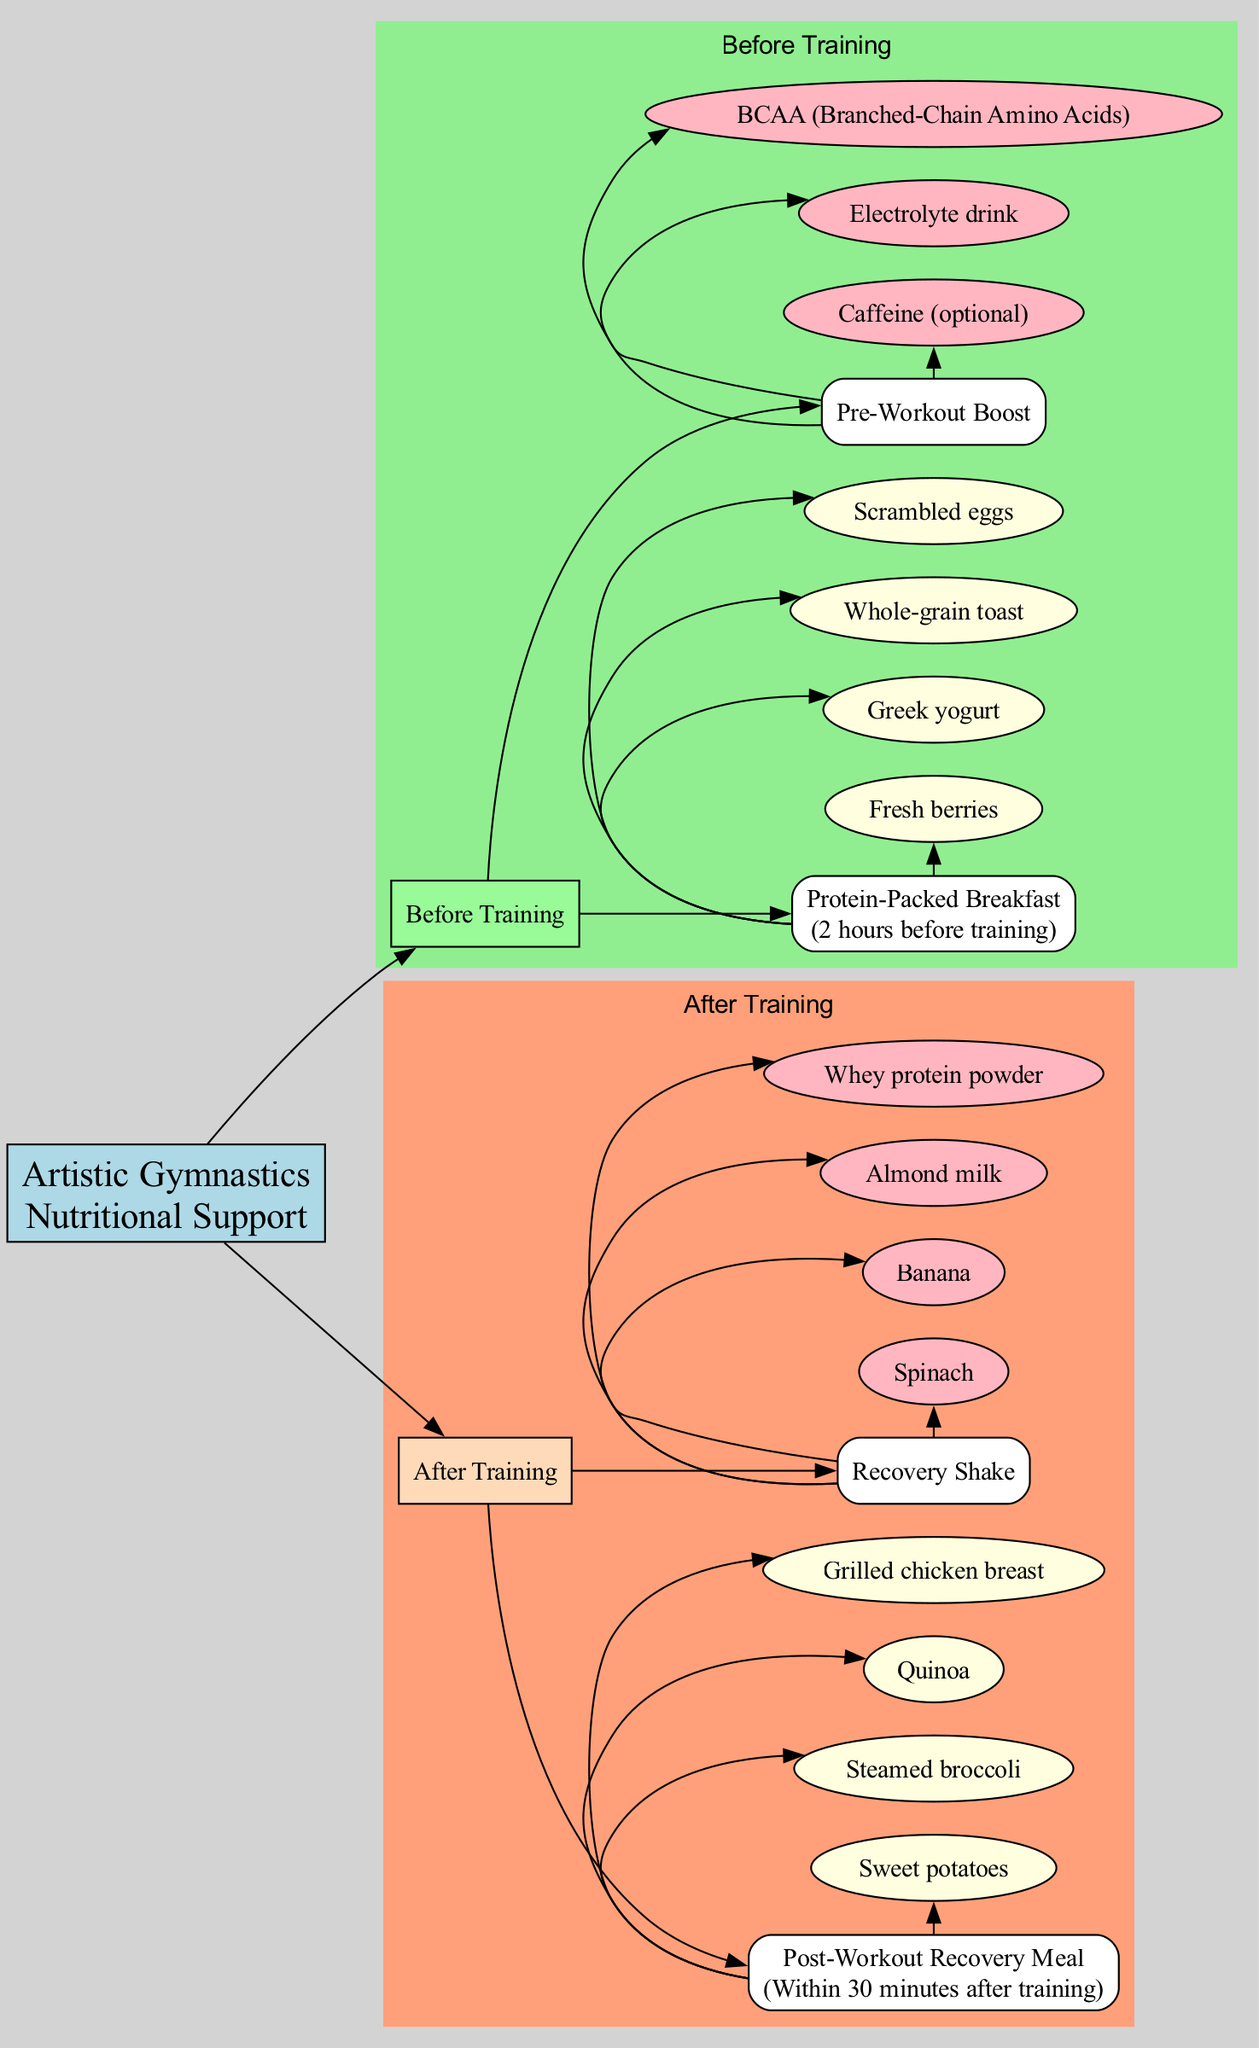What is the name of the meal before training? The diagram identifies a node under "Before Training" labeled as "Protein-Packed Breakfast." This is a specific detail directly found in the section for meals prior to training.
Answer: Protein-Packed Breakfast How long before training should the Protein-Packed Breakfast be consumed? The diagram provides a direct time reference linked to the "Protein-Packed Breakfast," stating it should be consumed "2 hours before training." This gives a clear time frame for this meal.
Answer: 2 hours What are the components of the Post-Workout Recovery Meal? By reviewing the section labeled "After Training," specifically the "Post-Workout Recovery Meal," I can list the components directly linked to this meal, which include "Grilled chicken breast," "Quinoa," "Steamed broccoli," and "Sweet potatoes." These components are each shown as linked nodes.
Answer: Grilled chicken breast, Quinoa, Steamed broccoli, Sweet potatoes How many supplements are listed before training? In the "Before Training" section, there is a node labeled "Pre-Workout Boost," which contains several components. By counting these nodes, which are "BCAA (Branched-Chain Amino Acids)," "Electrolyte drink," and "Caffeine (optional)," I find there are three supplements mentioned here.
Answer: 3 What is the timing for the Recovery Shake after training? The "Recovery Shake" is placed in the "After Training" section, but the diagram does not specify a timing for it like the meal. By looking closely, I see it follows the "Post-Workout Recovery Meal," which suggests it should be consumed as part of the recovery process but does not provide specific timing.
Answer: Not specified What are the components of the Pre-Workout Boost? The "Pre-Workout Boost" under "Before Training" is linked to multiple components, including "BCAA (Branched-Chain Amino Acids)," "Electrolyte drink," and "Caffeine (optional)." These details are provided as separate nodes under this supplement.
Answer: BCAA, Electrolyte drink, Caffeine Which meals correspond to training, before or after? The diagram distinctly splits into two main sections: "Before Training" and "After Training." The labels make it clear that there are designated meals pertaining to both time frames, indicating that each section contains meals corresponding to either before or after training.
Answer: Both What is the color associated with the After Training section? In the diagram, the attributed color for the "After Training" section is "lightsalmon," which is indicated by the attributes set in the subgraph of this part of the pathway.
Answer: lightsalmon 